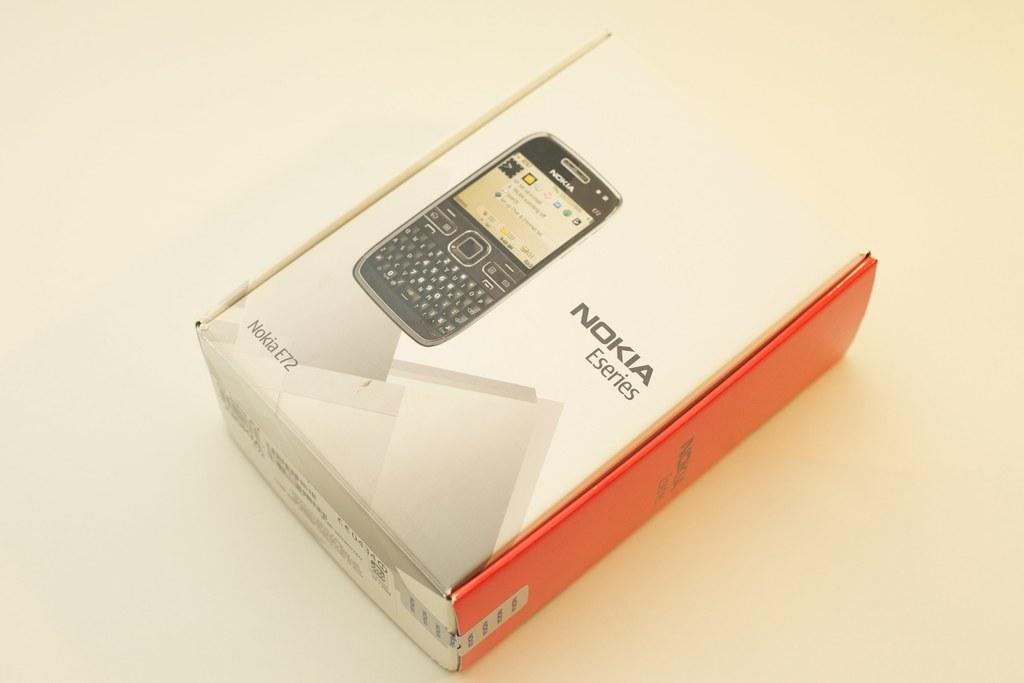<image>
Present a compact description of the photo's key features. A box that contains a Nokia Eseries phone rests on a table. 